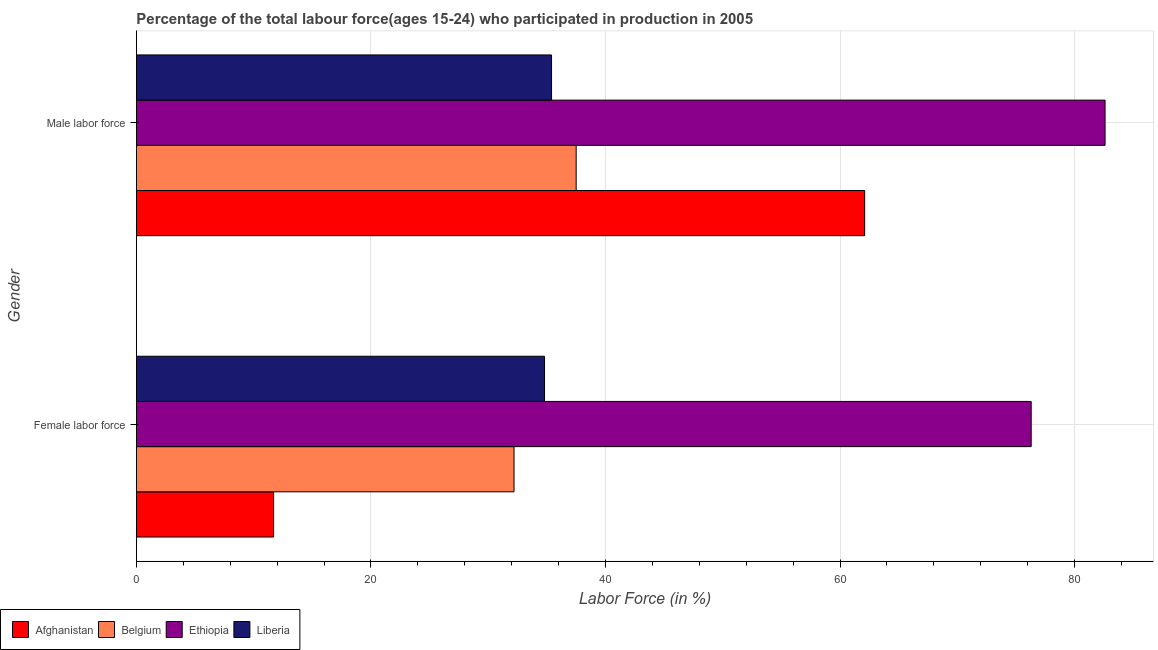How many bars are there on the 1st tick from the top?
Provide a short and direct response. 4. What is the label of the 2nd group of bars from the top?
Give a very brief answer. Female labor force. What is the percentage of female labor force in Belgium?
Your answer should be compact. 32.2. Across all countries, what is the maximum percentage of male labour force?
Make the answer very short. 82.6. Across all countries, what is the minimum percentage of female labor force?
Keep it short and to the point. 11.7. In which country was the percentage of male labour force maximum?
Your answer should be compact. Ethiopia. In which country was the percentage of female labor force minimum?
Give a very brief answer. Afghanistan. What is the total percentage of male labour force in the graph?
Provide a short and direct response. 217.6. What is the difference between the percentage of female labor force in Liberia and that in Afghanistan?
Give a very brief answer. 23.1. What is the difference between the percentage of male labour force in Liberia and the percentage of female labor force in Afghanistan?
Ensure brevity in your answer.  23.7. What is the average percentage of female labor force per country?
Keep it short and to the point. 38.75. What is the difference between the percentage of male labour force and percentage of female labor force in Afghanistan?
Offer a terse response. 50.4. What is the ratio of the percentage of female labor force in Belgium to that in Afghanistan?
Ensure brevity in your answer.  2.75. Is the percentage of male labour force in Liberia less than that in Afghanistan?
Make the answer very short. Yes. In how many countries, is the percentage of male labour force greater than the average percentage of male labour force taken over all countries?
Offer a terse response. 2. What does the 2nd bar from the top in Male labor force represents?
Your response must be concise. Ethiopia. What does the 4th bar from the bottom in Female labor force represents?
Provide a succinct answer. Liberia. How many bars are there?
Provide a short and direct response. 8. Does the graph contain any zero values?
Provide a succinct answer. No. Where does the legend appear in the graph?
Keep it short and to the point. Bottom left. What is the title of the graph?
Provide a succinct answer. Percentage of the total labour force(ages 15-24) who participated in production in 2005. What is the label or title of the Y-axis?
Keep it short and to the point. Gender. What is the Labor Force (in %) in Afghanistan in Female labor force?
Provide a short and direct response. 11.7. What is the Labor Force (in %) of Belgium in Female labor force?
Give a very brief answer. 32.2. What is the Labor Force (in %) of Ethiopia in Female labor force?
Give a very brief answer. 76.3. What is the Labor Force (in %) in Liberia in Female labor force?
Give a very brief answer. 34.8. What is the Labor Force (in %) in Afghanistan in Male labor force?
Make the answer very short. 62.1. What is the Labor Force (in %) of Belgium in Male labor force?
Ensure brevity in your answer.  37.5. What is the Labor Force (in %) in Ethiopia in Male labor force?
Keep it short and to the point. 82.6. What is the Labor Force (in %) of Liberia in Male labor force?
Your answer should be very brief. 35.4. Across all Gender, what is the maximum Labor Force (in %) of Afghanistan?
Provide a short and direct response. 62.1. Across all Gender, what is the maximum Labor Force (in %) of Belgium?
Your response must be concise. 37.5. Across all Gender, what is the maximum Labor Force (in %) in Ethiopia?
Your answer should be very brief. 82.6. Across all Gender, what is the maximum Labor Force (in %) of Liberia?
Your answer should be compact. 35.4. Across all Gender, what is the minimum Labor Force (in %) of Afghanistan?
Give a very brief answer. 11.7. Across all Gender, what is the minimum Labor Force (in %) of Belgium?
Provide a short and direct response. 32.2. Across all Gender, what is the minimum Labor Force (in %) in Ethiopia?
Your answer should be very brief. 76.3. Across all Gender, what is the minimum Labor Force (in %) of Liberia?
Keep it short and to the point. 34.8. What is the total Labor Force (in %) of Afghanistan in the graph?
Your answer should be compact. 73.8. What is the total Labor Force (in %) of Belgium in the graph?
Your answer should be very brief. 69.7. What is the total Labor Force (in %) in Ethiopia in the graph?
Ensure brevity in your answer.  158.9. What is the total Labor Force (in %) in Liberia in the graph?
Make the answer very short. 70.2. What is the difference between the Labor Force (in %) of Afghanistan in Female labor force and that in Male labor force?
Ensure brevity in your answer.  -50.4. What is the difference between the Labor Force (in %) in Belgium in Female labor force and that in Male labor force?
Your answer should be compact. -5.3. What is the difference between the Labor Force (in %) in Liberia in Female labor force and that in Male labor force?
Ensure brevity in your answer.  -0.6. What is the difference between the Labor Force (in %) of Afghanistan in Female labor force and the Labor Force (in %) of Belgium in Male labor force?
Provide a succinct answer. -25.8. What is the difference between the Labor Force (in %) of Afghanistan in Female labor force and the Labor Force (in %) of Ethiopia in Male labor force?
Provide a short and direct response. -70.9. What is the difference between the Labor Force (in %) in Afghanistan in Female labor force and the Labor Force (in %) in Liberia in Male labor force?
Your response must be concise. -23.7. What is the difference between the Labor Force (in %) in Belgium in Female labor force and the Labor Force (in %) in Ethiopia in Male labor force?
Ensure brevity in your answer.  -50.4. What is the difference between the Labor Force (in %) of Ethiopia in Female labor force and the Labor Force (in %) of Liberia in Male labor force?
Give a very brief answer. 40.9. What is the average Labor Force (in %) of Afghanistan per Gender?
Provide a succinct answer. 36.9. What is the average Labor Force (in %) in Belgium per Gender?
Offer a very short reply. 34.85. What is the average Labor Force (in %) in Ethiopia per Gender?
Provide a succinct answer. 79.45. What is the average Labor Force (in %) in Liberia per Gender?
Your answer should be very brief. 35.1. What is the difference between the Labor Force (in %) in Afghanistan and Labor Force (in %) in Belgium in Female labor force?
Provide a succinct answer. -20.5. What is the difference between the Labor Force (in %) of Afghanistan and Labor Force (in %) of Ethiopia in Female labor force?
Provide a short and direct response. -64.6. What is the difference between the Labor Force (in %) of Afghanistan and Labor Force (in %) of Liberia in Female labor force?
Your response must be concise. -23.1. What is the difference between the Labor Force (in %) of Belgium and Labor Force (in %) of Ethiopia in Female labor force?
Keep it short and to the point. -44.1. What is the difference between the Labor Force (in %) in Ethiopia and Labor Force (in %) in Liberia in Female labor force?
Provide a succinct answer. 41.5. What is the difference between the Labor Force (in %) of Afghanistan and Labor Force (in %) of Belgium in Male labor force?
Provide a short and direct response. 24.6. What is the difference between the Labor Force (in %) of Afghanistan and Labor Force (in %) of Ethiopia in Male labor force?
Your response must be concise. -20.5. What is the difference between the Labor Force (in %) of Afghanistan and Labor Force (in %) of Liberia in Male labor force?
Provide a succinct answer. 26.7. What is the difference between the Labor Force (in %) in Belgium and Labor Force (in %) in Ethiopia in Male labor force?
Make the answer very short. -45.1. What is the difference between the Labor Force (in %) in Belgium and Labor Force (in %) in Liberia in Male labor force?
Give a very brief answer. 2.1. What is the difference between the Labor Force (in %) in Ethiopia and Labor Force (in %) in Liberia in Male labor force?
Your answer should be compact. 47.2. What is the ratio of the Labor Force (in %) in Afghanistan in Female labor force to that in Male labor force?
Give a very brief answer. 0.19. What is the ratio of the Labor Force (in %) in Belgium in Female labor force to that in Male labor force?
Your response must be concise. 0.86. What is the ratio of the Labor Force (in %) of Ethiopia in Female labor force to that in Male labor force?
Make the answer very short. 0.92. What is the ratio of the Labor Force (in %) in Liberia in Female labor force to that in Male labor force?
Give a very brief answer. 0.98. What is the difference between the highest and the second highest Labor Force (in %) in Afghanistan?
Your answer should be very brief. 50.4. What is the difference between the highest and the second highest Labor Force (in %) in Liberia?
Keep it short and to the point. 0.6. What is the difference between the highest and the lowest Labor Force (in %) in Afghanistan?
Ensure brevity in your answer.  50.4. What is the difference between the highest and the lowest Labor Force (in %) in Belgium?
Make the answer very short. 5.3. What is the difference between the highest and the lowest Labor Force (in %) in Ethiopia?
Keep it short and to the point. 6.3. What is the difference between the highest and the lowest Labor Force (in %) in Liberia?
Give a very brief answer. 0.6. 